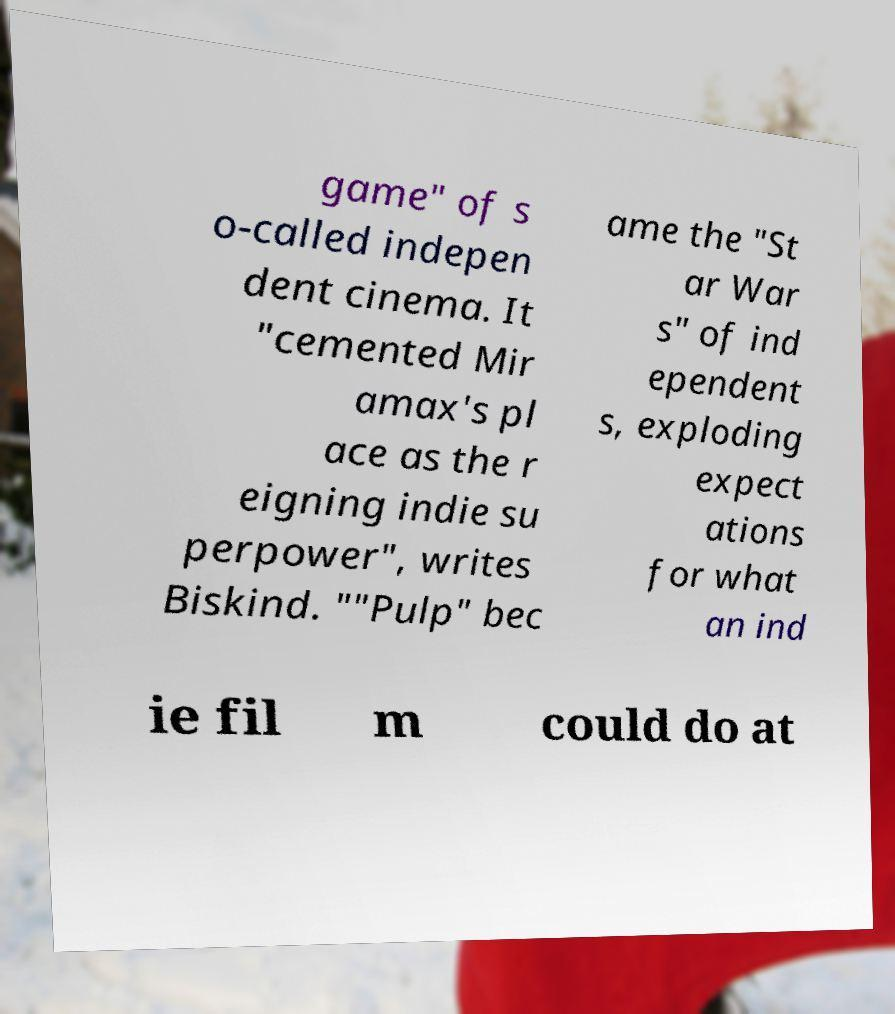What messages or text are displayed in this image? I need them in a readable, typed format. game" of s o-called indepen dent cinema. It "cemented Mir amax's pl ace as the r eigning indie su perpower", writes Biskind. ""Pulp" bec ame the "St ar War s" of ind ependent s, exploding expect ations for what an ind ie fil m could do at 